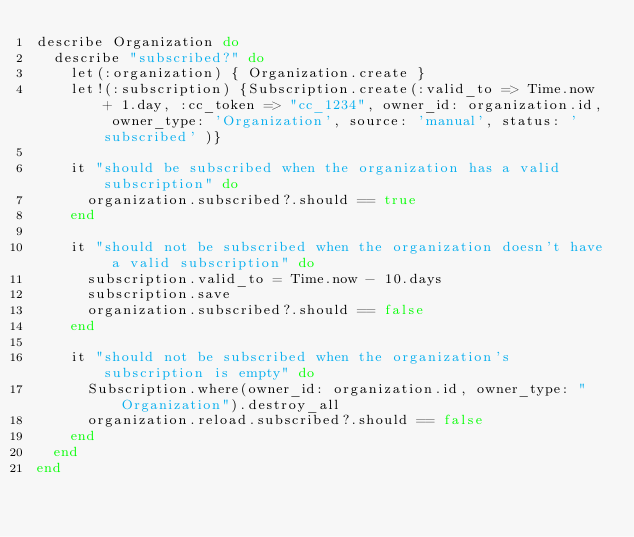<code> <loc_0><loc_0><loc_500><loc_500><_Ruby_>describe Organization do
  describe "subscribed?" do
    let(:organization) { Organization.create }
    let!(:subscription) {Subscription.create(:valid_to => Time.now + 1.day, :cc_token => "cc_1234", owner_id: organization.id, owner_type: 'Organization', source: 'manual', status: 'subscribed' )}

    it "should be subscribed when the organization has a valid subscription" do
      organization.subscribed?.should == true
    end

    it "should not be subscribed when the organization doesn't have a valid subscription" do
      subscription.valid_to = Time.now - 10.days
      subscription.save
      organization.subscribed?.should == false
    end

    it "should not be subscribed when the organization's subscription is empty" do
      Subscription.where(owner_id: organization.id, owner_type: "Organization").destroy_all
      organization.reload.subscribed?.should == false
    end
  end
end
</code> 